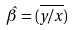<formula> <loc_0><loc_0><loc_500><loc_500>\hat { \beta } = ( \overline { y / x } )</formula> 